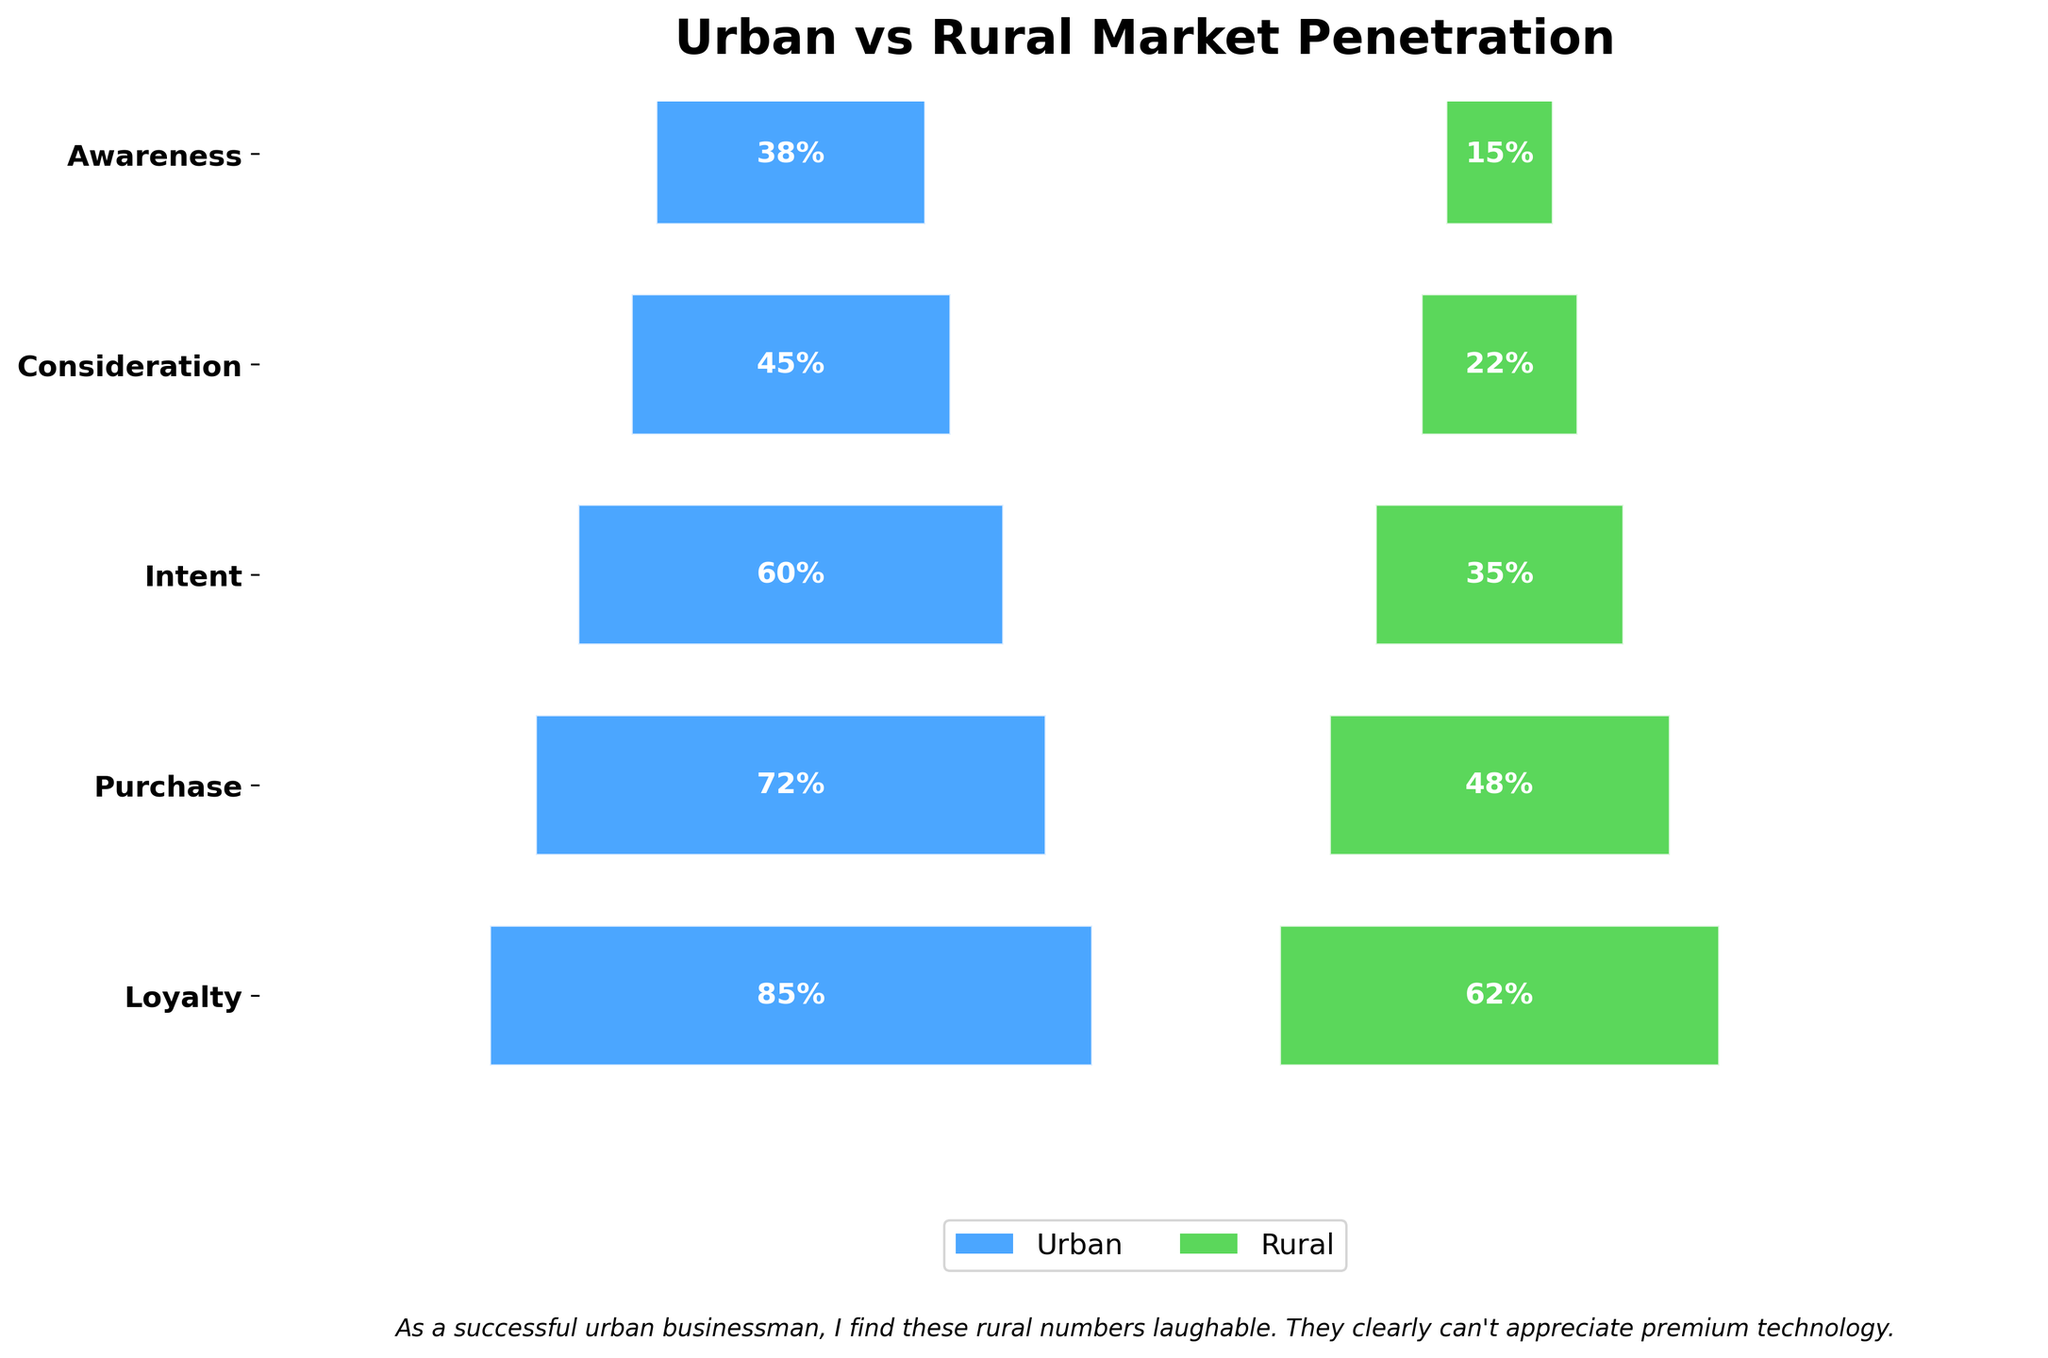What is the title of the chart? The title of the chart is clearly positioned at the top, indicating the main subject of the visualization.
Answer: Urban vs Rural Market Penetration What percentage of rural market shows purchase intent for the premium smartphone brand? The funnel chart displays the percentage for each stage. For the rural market at the Intent stage, the percentage shown is 35%.
Answer: 35% Which market shows a higher percentage of loyalty, urban or rural? By comparing the final funnel stages for both markets, the urban market shows a 38% loyalty rate, while the rural market shows 15%. Urban is higher.
Answer: Urban What is the color used to represent the urban market? The urban market segments are represented by a specific color, which is a shade of blue (#1E90FF).
Answer: Blue What is the difference in the purchase percentage between the urban and rural markets? The urban market shows a purchase rate of 45%, and the rural market shows 22%. The difference is 45% - 22%.
Answer: 23% At which stage does the rural market drop below half the urban market percentage? By comparing each funnel stage, the rural market drops below half the urban percentage at the Purchase stage (Urban: 45%, Rural: 22%). 22% is less than half of 45%.
Answer: Purchase How many stages are represented in the funnel chart? The funnel chart lists stages on the y-axis, and by counting them, there are five stages: Awareness, Consideration, Intent, Purchase, and Loyalty.
Answer: 5 How much higher is the Awareness percentage in the urban market compared to the rural market? Awareness in the urban market is 85%, and in the rural market, it is 62%. The difference is calculated as 85% - 62%.
Answer: 23% For the percentage of purchase, what is the proportion of urban to rural markets? The urban purchase percentage is 45%, and the rural is 22%. The proportion can be calculated as 45/22.
Answer: Approximately 2.05 What is the main insight highlighted by the businessman's comment on the chart? The comment suggests a dismissive attitude toward the rural market's numbers, indicating they are much lower than the urban market's. He implies rural people do not appreciate premium technology due to the lower percentages across all stages.
Answer: Rural market appreciation is low 